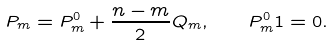Convert formula to latex. <formula><loc_0><loc_0><loc_500><loc_500>P _ { m } = P _ { m } ^ { 0 } + \frac { n - m } 2 Q _ { m } , \quad P _ { m } ^ { 0 } 1 = 0 .</formula> 